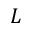Convert formula to latex. <formula><loc_0><loc_0><loc_500><loc_500>L</formula> 